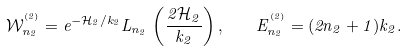Convert formula to latex. <formula><loc_0><loc_0><loc_500><loc_500>\mathcal { W } ^ { ^ { ( 2 ) } } _ { n _ { 2 } } = e ^ { - \mathcal { H } _ { 2 } / k _ { 2 } } L _ { n _ { 2 } } \, \left ( \frac { 2 \mathcal { H } _ { 2 } } { k _ { 2 } } \right ) , \quad E ^ { ^ { ( 2 ) } } _ { n _ { 2 } } = ( 2 n _ { 2 } + 1 ) k _ { 2 } .</formula> 